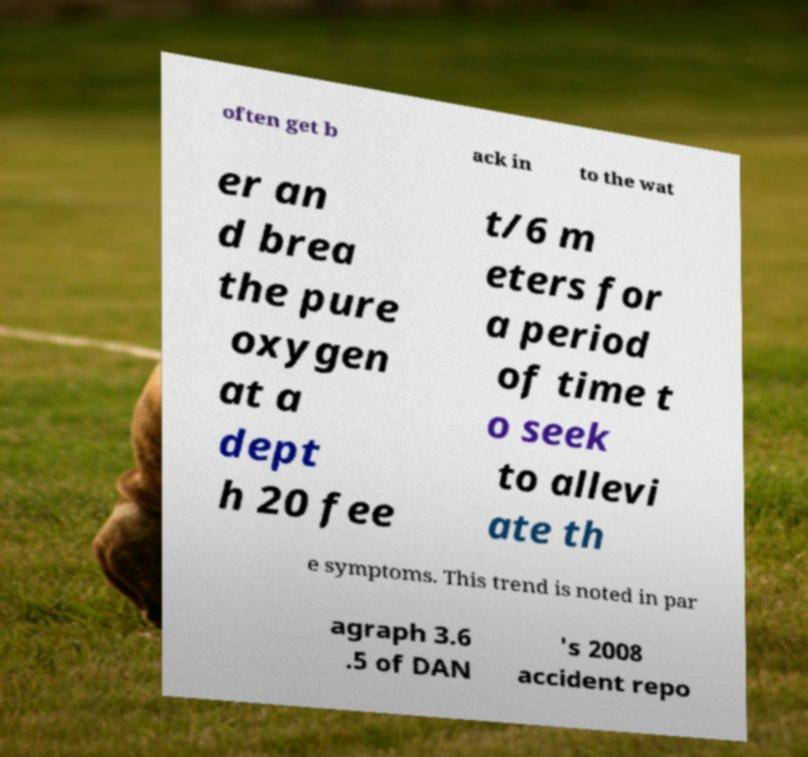What messages or text are displayed in this image? I need them in a readable, typed format. often get b ack in to the wat er an d brea the pure oxygen at a dept h 20 fee t/6 m eters for a period of time t o seek to allevi ate th e symptoms. This trend is noted in par agraph 3.6 .5 of DAN 's 2008 accident repo 